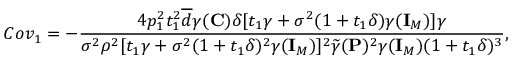<formula> <loc_0><loc_0><loc_500><loc_500>C o v _ { 1 } = - \frac { 4 p _ { 1 } ^ { 2 } t _ { 1 } ^ { 2 } \overline { d } \gamma ( { C } ) \delta [ t _ { 1 } \gamma + \sigma ^ { 2 } ( 1 + t _ { 1 } \delta ) \gamma ( { I } _ { M } ) ] \gamma } { \sigma ^ { 2 } \rho ^ { 2 } [ t _ { 1 } \gamma + \sigma ^ { 2 } ( 1 + t _ { 1 } \delta ) ^ { 2 } \gamma ( { I } _ { M } ) ] ^ { 2 } \widetilde { \gamma } ( { P } ) ^ { 2 } \gamma ( { I } _ { M } ) ( 1 + t _ { 1 } \delta ) ^ { 3 } } ,</formula> 